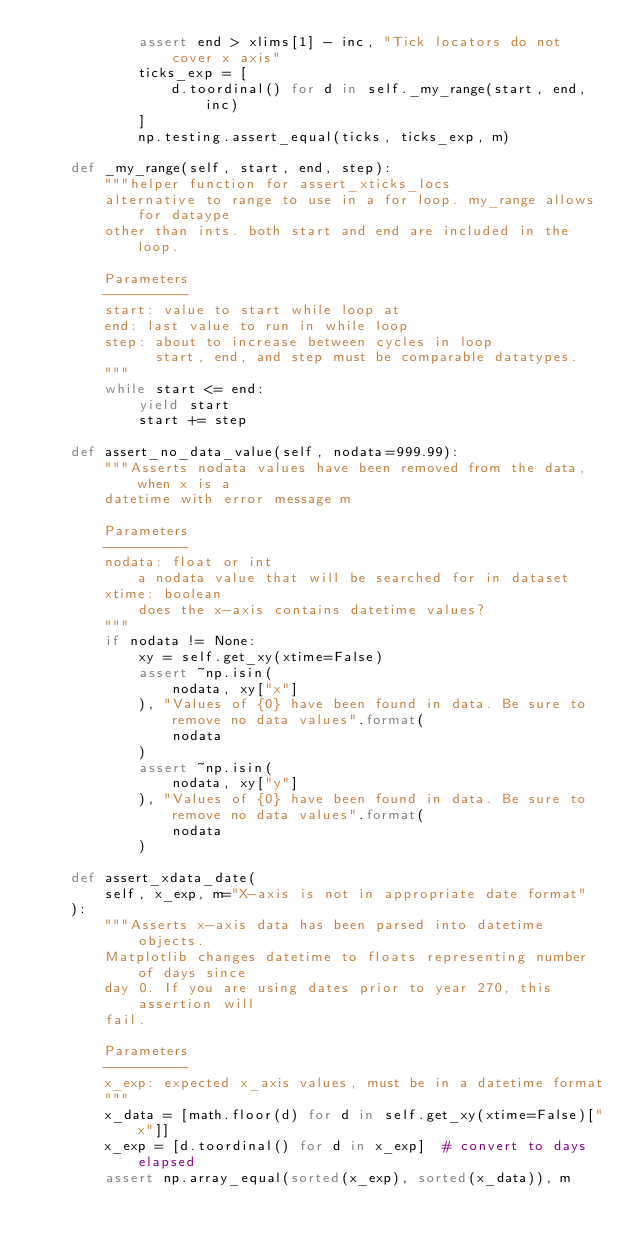Convert code to text. <code><loc_0><loc_0><loc_500><loc_500><_Python_>            assert end > xlims[1] - inc, "Tick locators do not cover x axis"
            ticks_exp = [
                d.toordinal() for d in self._my_range(start, end, inc)
            ]
            np.testing.assert_equal(ticks, ticks_exp, m)

    def _my_range(self, start, end, step):
        """helper function for assert_xticks_locs
        alternative to range to use in a for loop. my_range allows for dataype
        other than ints. both start and end are included in the loop.

        Parameters
        ----------
        start: value to start while loop at
        end: last value to run in while loop
        step: about to increase between cycles in loop
              start, end, and step must be comparable datatypes.
        """
        while start <= end:
            yield start
            start += step

    def assert_no_data_value(self, nodata=999.99):
        """Asserts nodata values have been removed from the data, when x is a
        datetime with error message m

        Parameters
        ----------
        nodata: float or int
            a nodata value that will be searched for in dataset
        xtime: boolean
            does the x-axis contains datetime values?
        """
        if nodata != None:
            xy = self.get_xy(xtime=False)
            assert ~np.isin(
                nodata, xy["x"]
            ), "Values of {0} have been found in data. Be sure to remove no data values".format(
                nodata
            )
            assert ~np.isin(
                nodata, xy["y"]
            ), "Values of {0} have been found in data. Be sure to remove no data values".format(
                nodata
            )

    def assert_xdata_date(
        self, x_exp, m="X-axis is not in appropriate date format"
    ):
        """Asserts x-axis data has been parsed into datetime objects.
        Matplotlib changes datetime to floats representing number of days since
        day 0. If you are using dates prior to year 270, this assertion will
        fail.

        Parameters
        ----------
        x_exp: expected x_axis values, must be in a datetime format
        """
        x_data = [math.floor(d) for d in self.get_xy(xtime=False)["x"]]
        x_exp = [d.toordinal() for d in x_exp]  # convert to days elapsed
        assert np.array_equal(sorted(x_exp), sorted(x_data)), m
</code> 